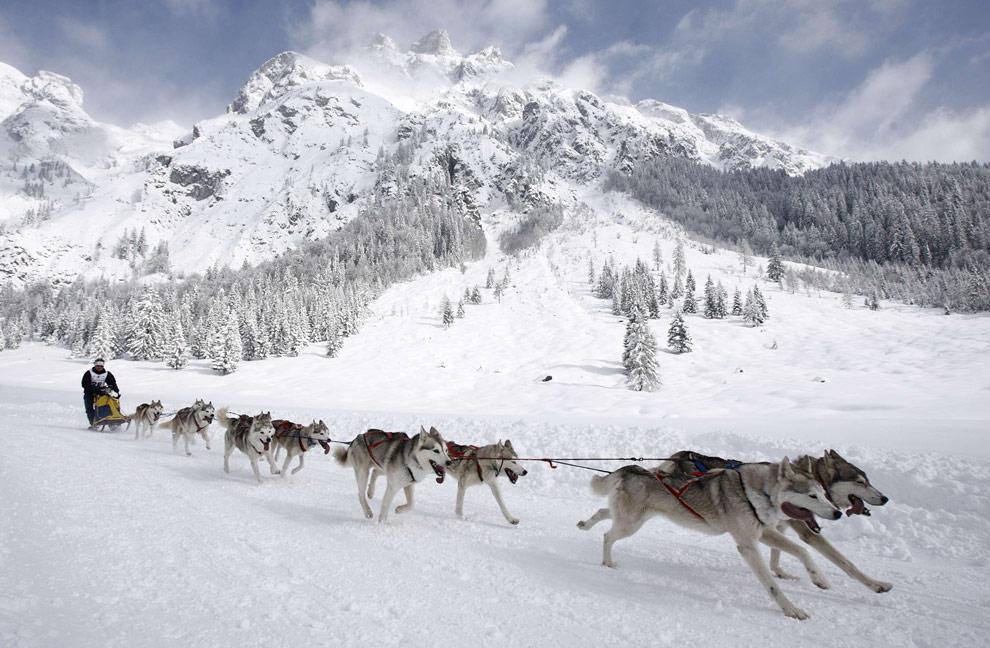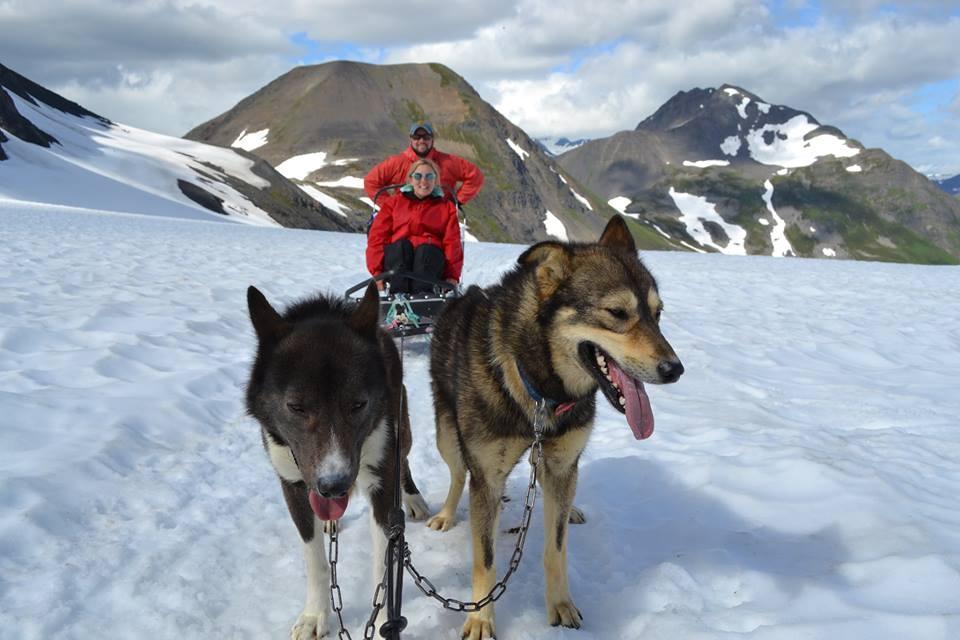The first image is the image on the left, the second image is the image on the right. For the images displayed, is the sentence "An image shows a sled dog team heading rightward and downward." factually correct? Answer yes or no. Yes. The first image is the image on the left, the second image is the image on the right. Assess this claim about the two images: "The right image shows a dog sled team heading straight toward the camera.". Correct or not? Answer yes or no. Yes. The first image is the image on the left, the second image is the image on the right. Examine the images to the left and right. Is the description "All of the humans in the right photo are wearing red jackets." accurate? Answer yes or no. Yes. 